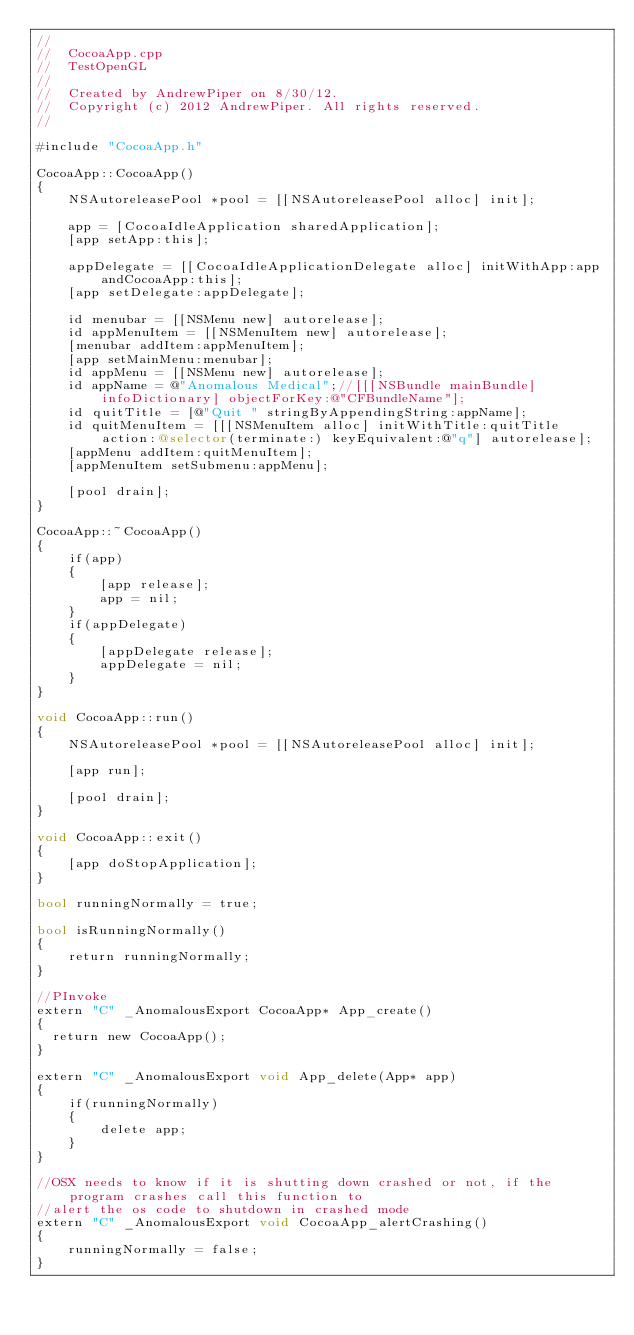<code> <loc_0><loc_0><loc_500><loc_500><_ObjectiveC_>//
//  CocoaApp.cpp
//  TestOpenGL
//
//  Created by AndrewPiper on 8/30/12.
//  Copyright (c) 2012 AndrewPiper. All rights reserved.
//

#include "CocoaApp.h"

CocoaApp::CocoaApp()
{
    NSAutoreleasePool *pool = [[NSAutoreleasePool alloc] init];
    
    app = [CocoaIdleApplication sharedApplication];
    [app setApp:this];
    
    appDelegate = [[CocoaIdleApplicationDelegate alloc] initWithApp:app andCocoaApp:this];
    [app setDelegate:appDelegate];
    
    id menubar = [[NSMenu new] autorelease];
    id appMenuItem = [[NSMenuItem new] autorelease];
    [menubar addItem:appMenuItem];
    [app setMainMenu:menubar];
    id appMenu = [[NSMenu new] autorelease];
    id appName = @"Anomalous Medical";//[[[NSBundle mainBundle] infoDictionary] objectForKey:@"CFBundleName"];
    id quitTitle = [@"Quit " stringByAppendingString:appName];
    id quitMenuItem = [[[NSMenuItem alloc] initWithTitle:quitTitle action:@selector(terminate:) keyEquivalent:@"q"] autorelease];
    [appMenu addItem:quitMenuItem];
    [appMenuItem setSubmenu:appMenu];
    
    [pool drain];
}

CocoaApp::~CocoaApp()
{
    if(app)
    {
        [app release];
        app = nil;
    }
    if(appDelegate)
    {
        [appDelegate release];
        appDelegate = nil;
    }
}

void CocoaApp::run()
{
    NSAutoreleasePool *pool = [[NSAutoreleasePool alloc] init];
    
    [app run];
    
    [pool drain];
}

void CocoaApp::exit()
{
    [app doStopApplication];
}

bool runningNormally = true;

bool isRunningNormally()
{
    return runningNormally;
}

//PInvoke
extern "C" _AnomalousExport CocoaApp* App_create()
{
	return new CocoaApp();
}

extern "C" _AnomalousExport void App_delete(App* app)
{
    if(runningNormally)
    {
        delete app;
    }
}

//OSX needs to know if it is shutting down crashed or not, if the program crashes call this function to
//alert the os code to shutdown in crashed mode
extern "C" _AnomalousExport void CocoaApp_alertCrashing()
{
    runningNormally = false;
}</code> 